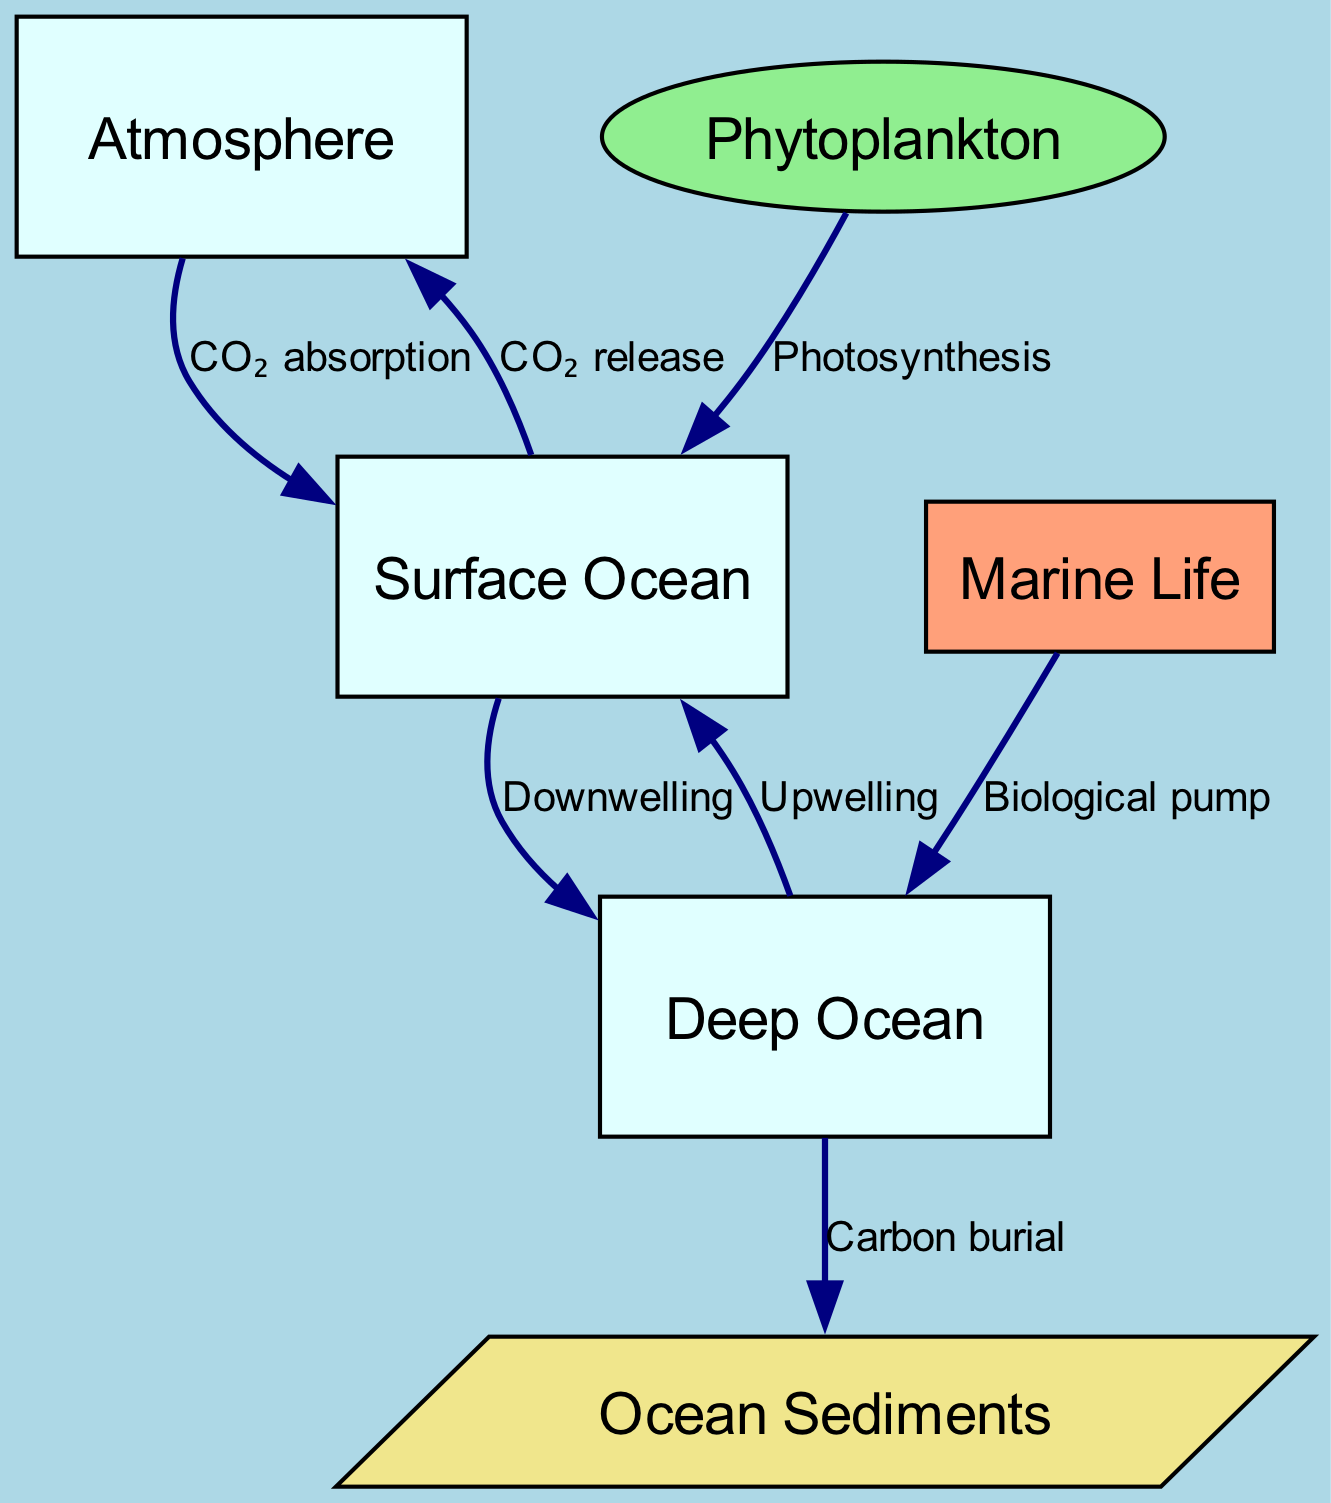What are the nodes in the diagram? The nodes present in the diagram are the atmosphere, surface ocean, deep ocean, marine life, sediments, and phytoplankton. Each of these nodes represents key components of the oceanic carbon cycle.
Answer: atmosphere, surface ocean, deep ocean, marine life, sediments, phytoplankton How many edges are represented in the diagram? The diagram contains a total of 7 edges, each representing a different flow or interaction between the nodes that are essential to the carbon cycle process.
Answer: 7 What process leads to CO₂ absorption by the surface ocean? The process leading to CO₂ absorption by the surface ocean is the direct interaction with the atmosphere, where carbon dioxide diffuses from the atmosphere into the surface ocean.
Answer: CO₂ absorption What is the relationship between surface ocean and deep ocean? The relationship between the surface ocean and deep ocean is characterized by downwelling and upwelling; the surface ocean sends water down to the deep ocean (downwelling) and can bring water back up to the surface (upwelling).
Answer: Downwelling and upwelling Which node contributes to the biological pump in the deep ocean? The node that contributes to the biological pump in the deep ocean is marine life, which plays a crucial role in transferring organic carbon from the surface to deeper waters through the consumption and excretion processes.
Answer: Marine life How does phytoplankton impact carbon levels in the surface ocean? Phytoplankton impacts carbon levels in the surface ocean by conducting photosynthesis, which utilizes carbon dioxide from the surface ocean and reduces its concentration, playing a critical role in regulating carbon levels.
Answer: Photosynthesis What happens to carbon in the deep ocean over time? Over time, carbon in the deep ocean undergoes carbon burial, which refers to the process of carbon being deposited and stored in ocean sediments, effectively sequestering it long-term.
Answer: Carbon burial 